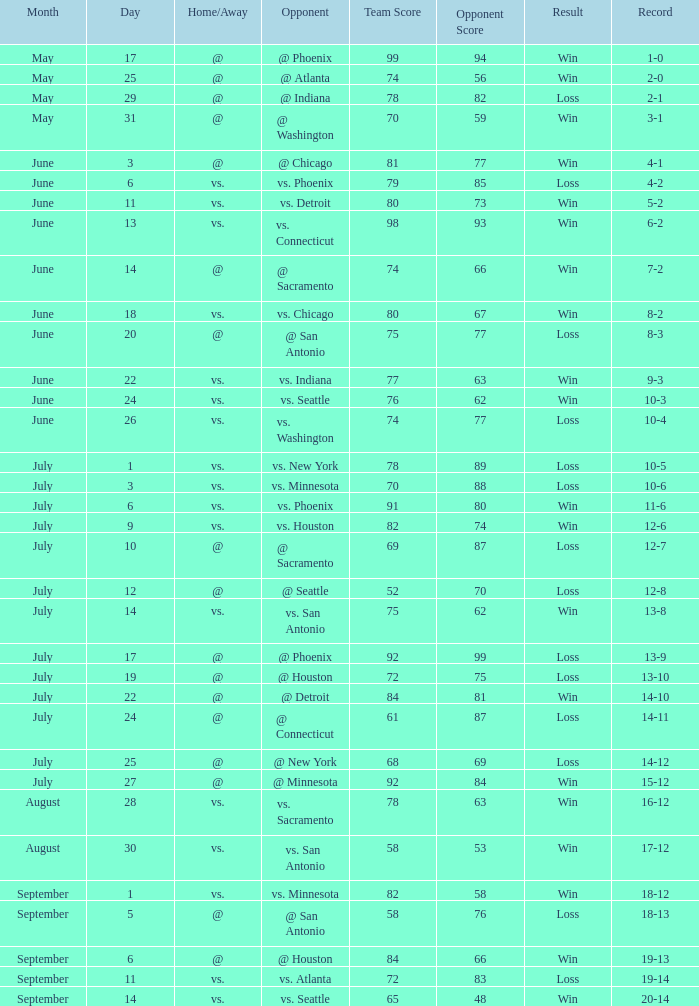What is the Record of the game on September 6? 19-13. 